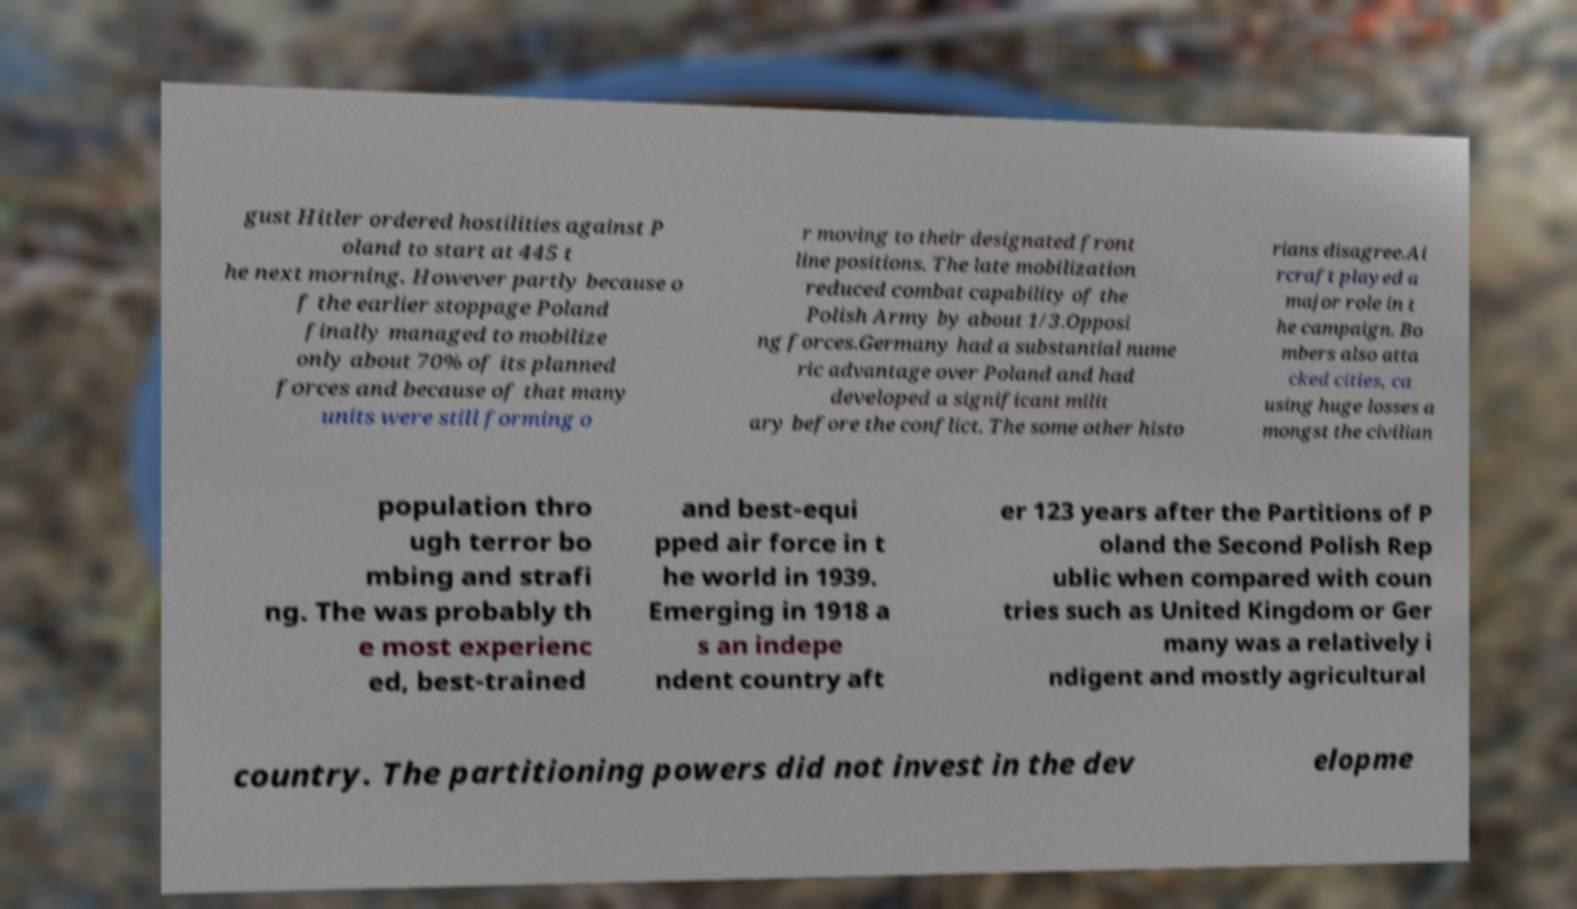I need the written content from this picture converted into text. Can you do that? gust Hitler ordered hostilities against P oland to start at 445 t he next morning. However partly because o f the earlier stoppage Poland finally managed to mobilize only about 70% of its planned forces and because of that many units were still forming o r moving to their designated front line positions. The late mobilization reduced combat capability of the Polish Army by about 1/3.Opposi ng forces.Germany had a substantial nume ric advantage over Poland and had developed a significant milit ary before the conflict. The some other histo rians disagree.Ai rcraft played a major role in t he campaign. Bo mbers also atta cked cities, ca using huge losses a mongst the civilian population thro ugh terror bo mbing and strafi ng. The was probably th e most experienc ed, best-trained and best-equi pped air force in t he world in 1939. Emerging in 1918 a s an indepe ndent country aft er 123 years after the Partitions of P oland the Second Polish Rep ublic when compared with coun tries such as United Kingdom or Ger many was a relatively i ndigent and mostly agricultural country. The partitioning powers did not invest in the dev elopme 